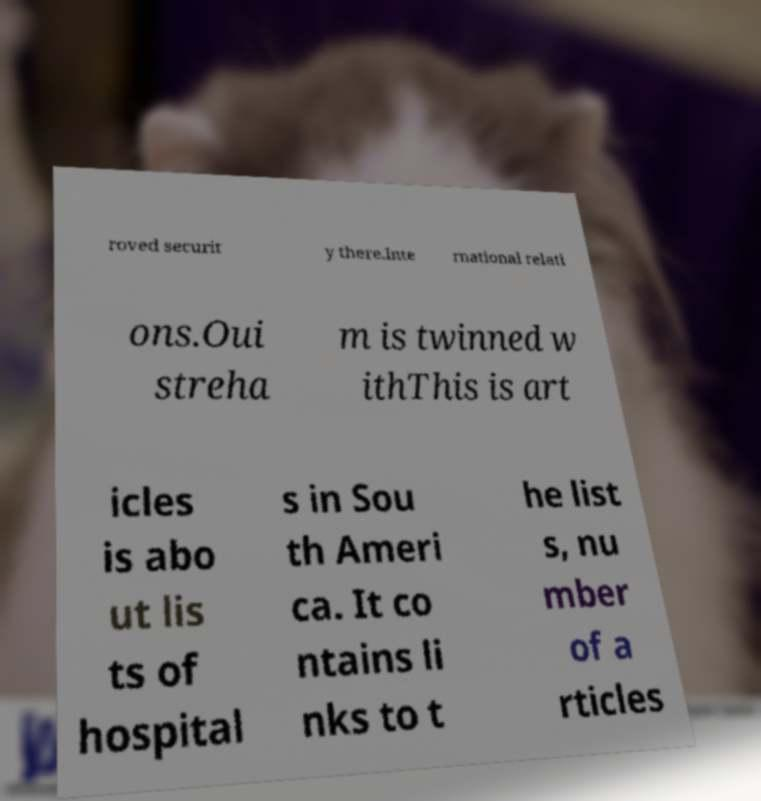I need the written content from this picture converted into text. Can you do that? roved securit y there.Inte rnational relati ons.Oui streha m is twinned w ithThis is art icles is abo ut lis ts of hospital s in Sou th Ameri ca. It co ntains li nks to t he list s, nu mber of a rticles 